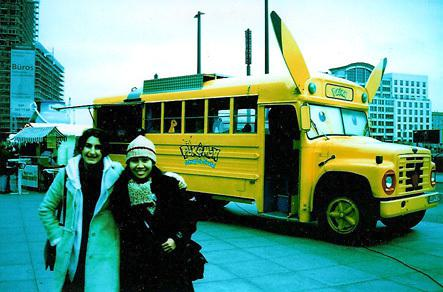Is there a bus in the image? Yes 